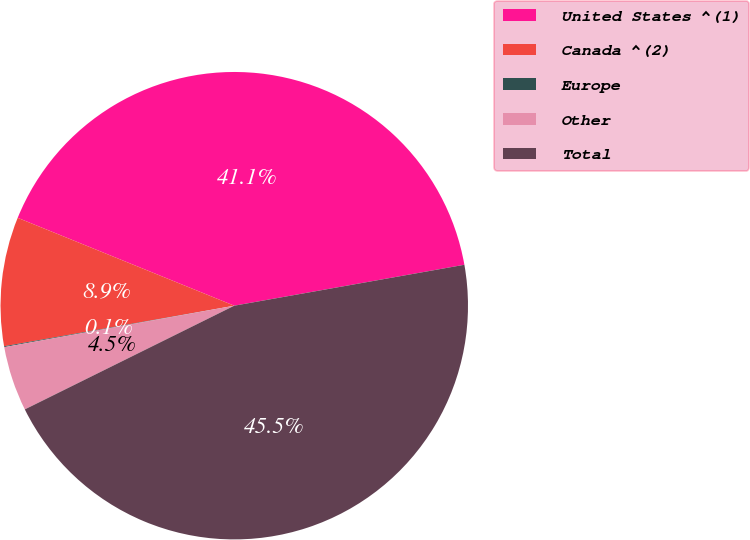Convert chart to OTSL. <chart><loc_0><loc_0><loc_500><loc_500><pie_chart><fcel>United States ^(1)<fcel>Canada ^(2)<fcel>Europe<fcel>Other<fcel>Total<nl><fcel>41.06%<fcel>8.91%<fcel>0.06%<fcel>4.48%<fcel>45.48%<nl></chart> 